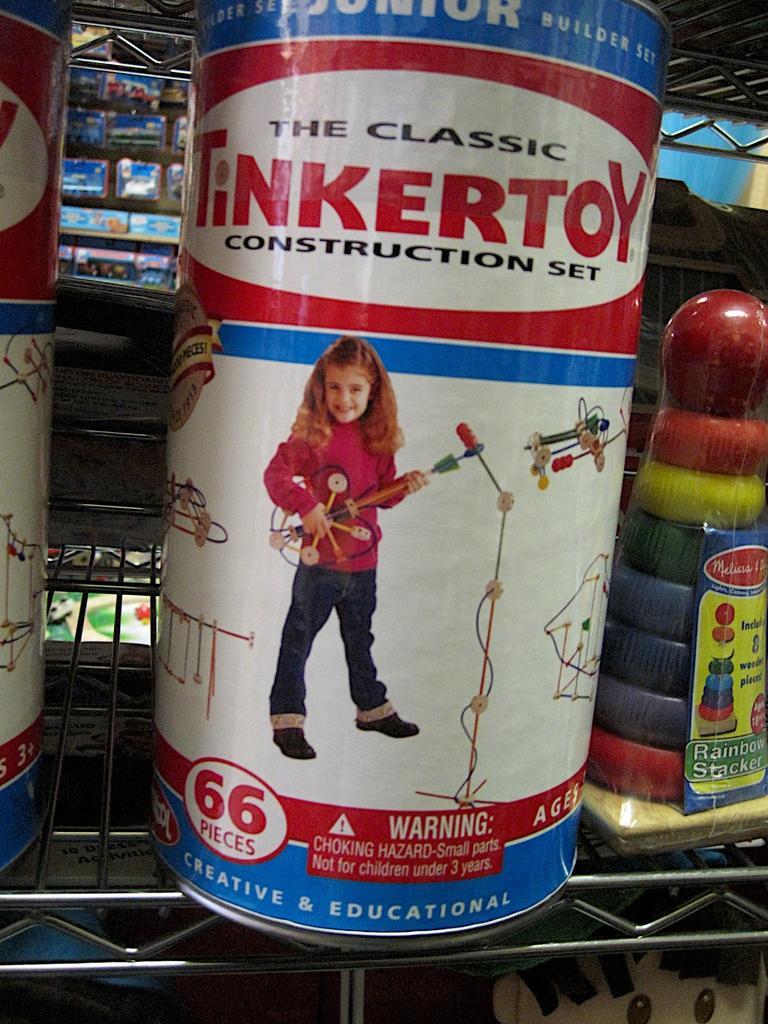Please provide a concise description of this image. In this image we can see tins and an object placed on the rack. In the background there are boxes. 